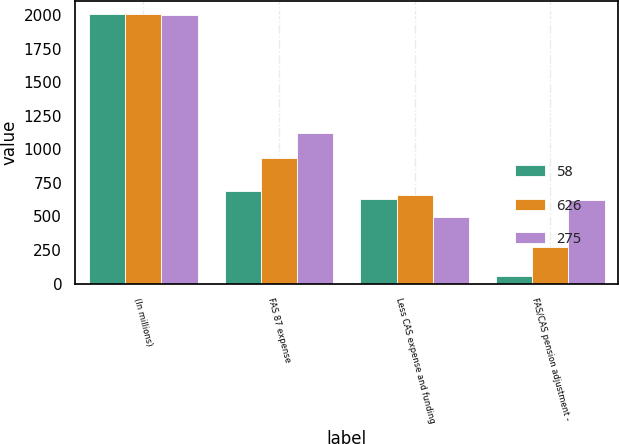Convert chart. <chart><loc_0><loc_0><loc_500><loc_500><stacked_bar_chart><ecel><fcel>(In millions)<fcel>FAS 87 expense<fcel>Less CAS expense and funding<fcel>FAS/CAS pension adjustment -<nl><fcel>58<fcel>2007<fcel>687<fcel>629<fcel>58<nl><fcel>626<fcel>2006<fcel>938<fcel>663<fcel>275<nl><fcel>275<fcel>2005<fcel>1124<fcel>498<fcel>626<nl></chart> 